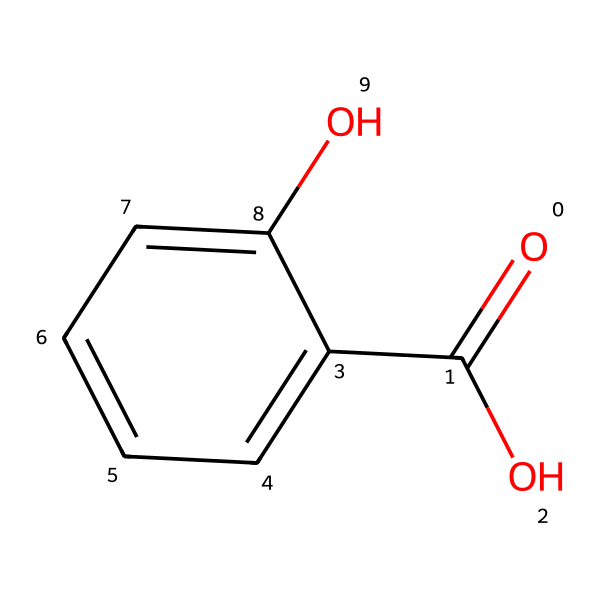What is the molecular formula of salicylic acid? The molecular formula can be derived from counting the number of each type of atom represented in the SMILES notation. The chemical contains 7 carbon atoms, 6 hydrogen atoms, and 3 oxygen atoms, leading to the formula C7H6O3.
Answer: C7H6O3 How many rings does salicylic acid contain? The visual representation indicates a single benzene ring, which is part of the overall structure. The rest of the molecule connects to this ring. Therefore, there is one ring.
Answer: 1 Which functional groups are present in salicylic acid? By analyzing the structure within the SMILES, we see the presence of a carboxylic acid group (-COOH) and a hydroxyl group (-OH) attached to the benzene ring. Therefore, both functional groups are present.
Answer: carboxylic acid and hydroxyl What is the role of the hydroxyl group in salicylic acid's antifungal properties? The hydroxyl group contributes to the molecule's ability to disrupt fungal cell walls and interfere with their metabolic processes. This functional group's polarity may also enhance solubility in biological systems, aiding antifungal activity.
Answer: disrupts fungal cell walls How does salicylic acid differ from its ester derivative, aspirin? The key difference lies in the acetylation of the hydroxyl group in aspirin, replacing the -OH group with an acetyl group (-OCOCH3), which alters its properties and therapeutic effects compared to salicylic acid.
Answer: acetylation of -OH What is the significance of the carboxylic acid group's acidity in salicylic acid's function? The carboxylic acid group contributes to the molecule's acidic nature, which is crucial for its activity against pathogens and influences its solubility and interaction with biological targets, enhancing its antifungal effects.
Answer: contributes to acidity What is the anti-inflammatory property of salicylic acid related to its structure? Salicylic acid can inhibit the enzyme cyclooxygenase, which is involved in the inflammatory pathway. The specific arrangement of the benzene ring and functional groups allows for interaction with this enzyme, reducing inflammation.
Answer: inhibits cyclooxygenase 